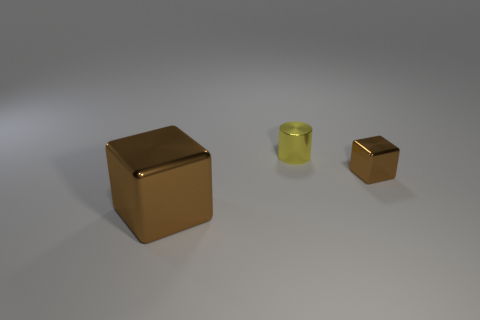There is a tiny thing that is the same color as the big block; what shape is it?
Provide a short and direct response. Cube. Is there a blue cylinder?
Ensure brevity in your answer.  No. The brown shiny thing left of the metallic cylinder has what shape?
Offer a very short reply. Cube. What number of brown things are to the left of the yellow metallic cylinder and right of the big cube?
Offer a terse response. 0. What number of other objects are the same size as the yellow cylinder?
Your response must be concise. 1. There is a brown metal object in front of the small brown cube; is it the same shape as the brown metal thing that is behind the big brown metallic thing?
Your answer should be very brief. Yes. What number of objects are either large rubber balls or metal blocks that are in front of the tiny brown metal object?
Provide a short and direct response. 1. What is the thing that is in front of the yellow thing and behind the big brown object made of?
Provide a succinct answer. Metal. Are there any other things that have the same shape as the large shiny object?
Your answer should be very brief. Yes. What color is the tiny thing that is the same material as the small block?
Offer a very short reply. Yellow. 